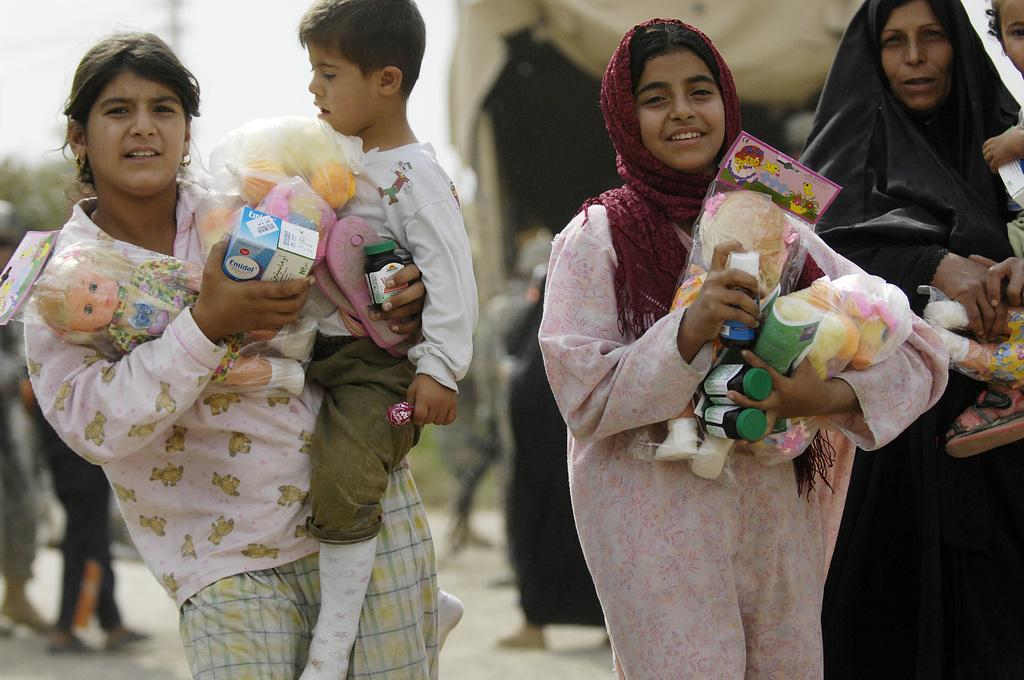How many women are present in the image? There are three women in the image. What are two of the women doing with the children? Two of the women are holding children. What else are the women holding in the image? All three women are holding toys. Can you describe the background of the image? The background of the image is blurred. What type of quince can be seen in the image? There is no quince present in the image. Can you tell me how many spades are being used by the women in the image? There are no spades visible in the image. 